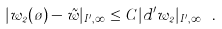Convert formula to latex. <formula><loc_0><loc_0><loc_500><loc_500>| w _ { 2 } ( \tau ) - \tilde { w } | _ { I ^ { \prime } , \infty } \leq C | d ^ { \prime } w _ { 2 } | _ { I ^ { \prime } , \infty } \ .</formula> 